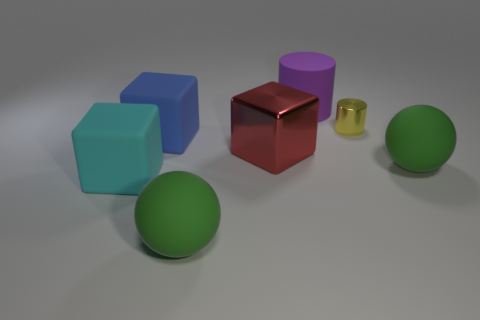Add 3 large cyan things. How many objects exist? 10 Subtract all blocks. How many objects are left? 4 Subtract all blue matte things. Subtract all big cyan rubber objects. How many objects are left? 5 Add 1 tiny things. How many tiny things are left? 2 Add 3 brown cubes. How many brown cubes exist? 3 Subtract 0 cyan balls. How many objects are left? 7 